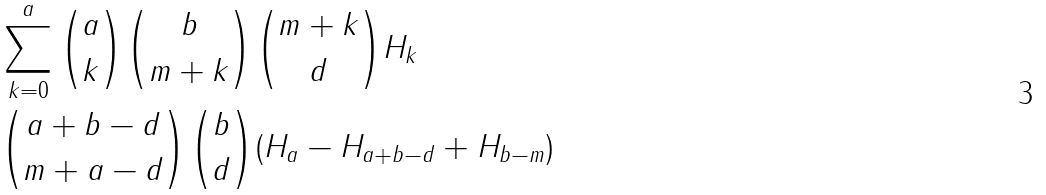<formula> <loc_0><loc_0><loc_500><loc_500>& \sum _ { k = 0 } ^ { a } \binom { a } { k } \binom { b } { m + k } \binom { m + k } { d } H _ { k } \\ & \binom { a + b - d } { m + a - d } \binom { b } { d } ( H _ { a } - H _ { a + b - d } + H _ { b - m } )</formula> 